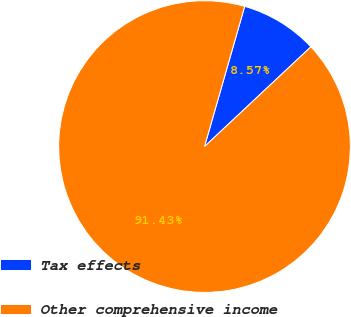Convert chart to OTSL. <chart><loc_0><loc_0><loc_500><loc_500><pie_chart><fcel>Tax effects<fcel>Other comprehensive income<nl><fcel>8.57%<fcel>91.43%<nl></chart> 